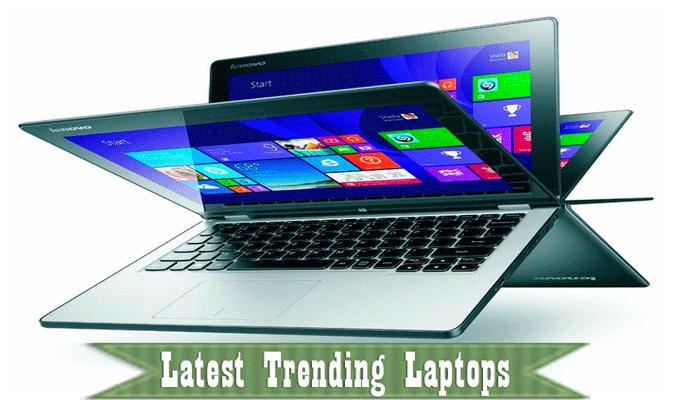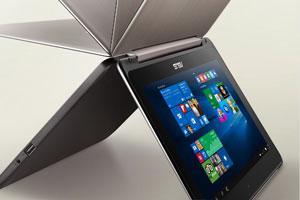The first image is the image on the left, the second image is the image on the right. Examine the images to the left and right. Is the description "A pen is touching the screen in one of the images." accurate? Answer yes or no. No. The first image is the image on the left, the second image is the image on the right. Evaluate the accuracy of this statement regarding the images: "Right image shows a laptop displayed like an inverted book with its pages fanning out.". Is it true? Answer yes or no. Yes. 